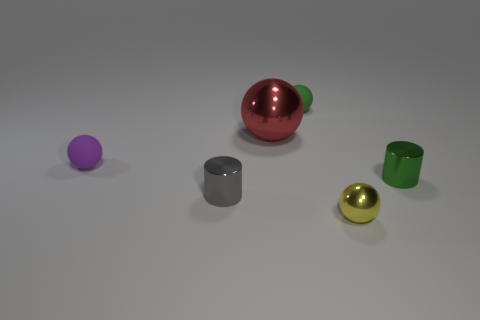What size is the metal cylinder on the left side of the ball that is in front of the green object that is on the right side of the small green ball?
Your answer should be compact. Small. Is the shape of the tiny green shiny thing the same as the small thing that is in front of the gray shiny cylinder?
Give a very brief answer. No. Is there a tiny shiny cube of the same color as the big shiny object?
Make the answer very short. No. What number of cubes are tiny blue shiny things or small objects?
Your answer should be compact. 0. Is there a big red metallic thing that has the same shape as the small gray object?
Give a very brief answer. No. What number of other objects are there of the same color as the big object?
Your response must be concise. 0. Is the number of yellow balls behind the small yellow ball less than the number of tiny brown spheres?
Your answer should be very brief. No. How many purple objects are there?
Your answer should be very brief. 1. How many large cyan objects have the same material as the big red ball?
Make the answer very short. 0. What number of things are spheres left of the tiny yellow metal object or metallic spheres?
Offer a terse response. 4. 